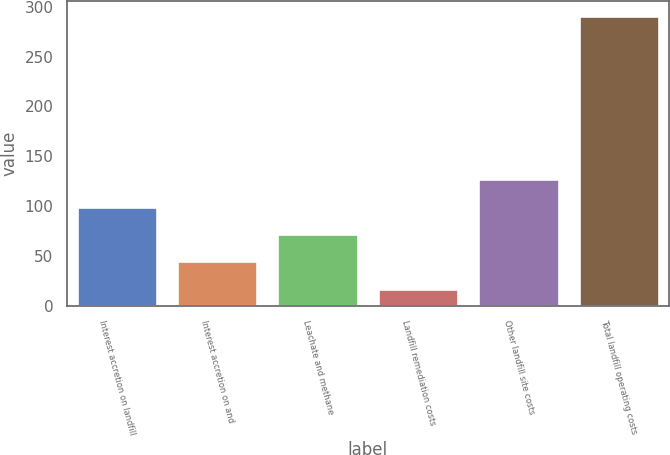Convert chart. <chart><loc_0><loc_0><loc_500><loc_500><bar_chart><fcel>Interest accretion on landfill<fcel>Interest accretion on and<fcel>Leachate and methane<fcel>Landfill remediation costs<fcel>Other landfill site costs<fcel>Total landfill operating costs<nl><fcel>99.2<fcel>44.4<fcel>71.8<fcel>17<fcel>126.6<fcel>291<nl></chart> 